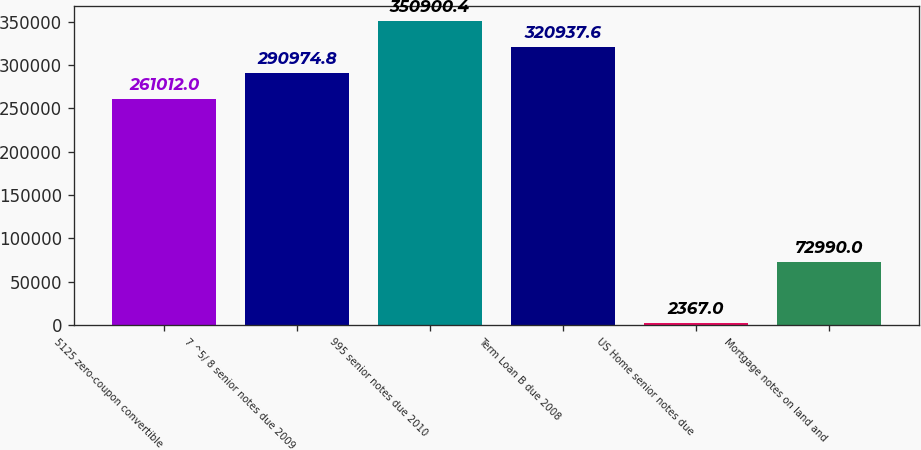Convert chart to OTSL. <chart><loc_0><loc_0><loc_500><loc_500><bar_chart><fcel>5125 zero-coupon convertible<fcel>7 ^5/ 8 senior notes due 2009<fcel>995 senior notes due 2010<fcel>Term Loan B due 2008<fcel>US Home senior notes due<fcel>Mortgage notes on land and<nl><fcel>261012<fcel>290975<fcel>350900<fcel>320938<fcel>2367<fcel>72990<nl></chart> 